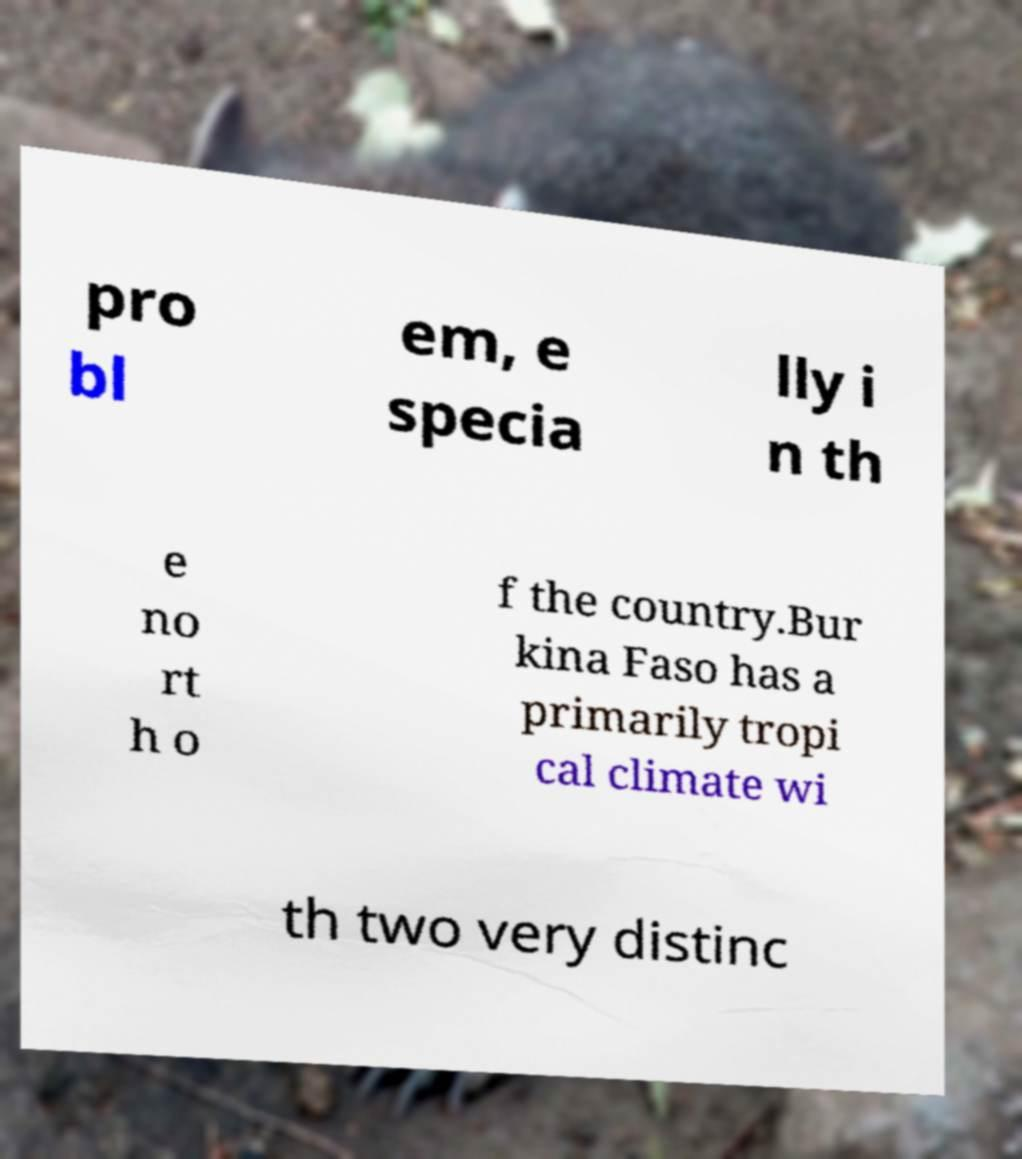Please read and relay the text visible in this image. What does it say? pro bl em, e specia lly i n th e no rt h o f the country.Bur kina Faso has a primarily tropi cal climate wi th two very distinc 